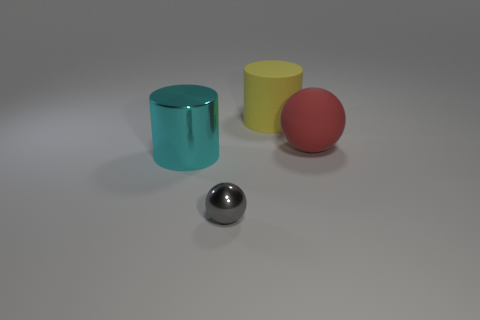There is a large yellow matte cylinder; are there any matte balls to the left of it? no 